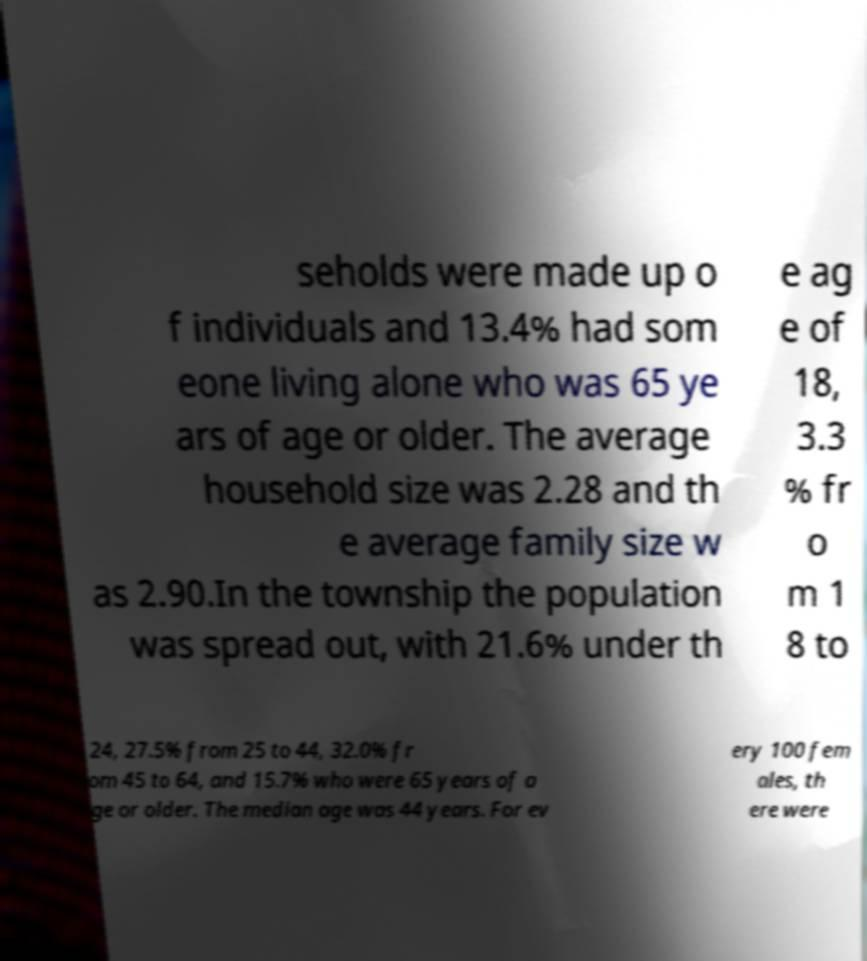Can you accurately transcribe the text from the provided image for me? seholds were made up o f individuals and 13.4% had som eone living alone who was 65 ye ars of age or older. The average household size was 2.28 and th e average family size w as 2.90.In the township the population was spread out, with 21.6% under th e ag e of 18, 3.3 % fr o m 1 8 to 24, 27.5% from 25 to 44, 32.0% fr om 45 to 64, and 15.7% who were 65 years of a ge or older. The median age was 44 years. For ev ery 100 fem ales, th ere were 